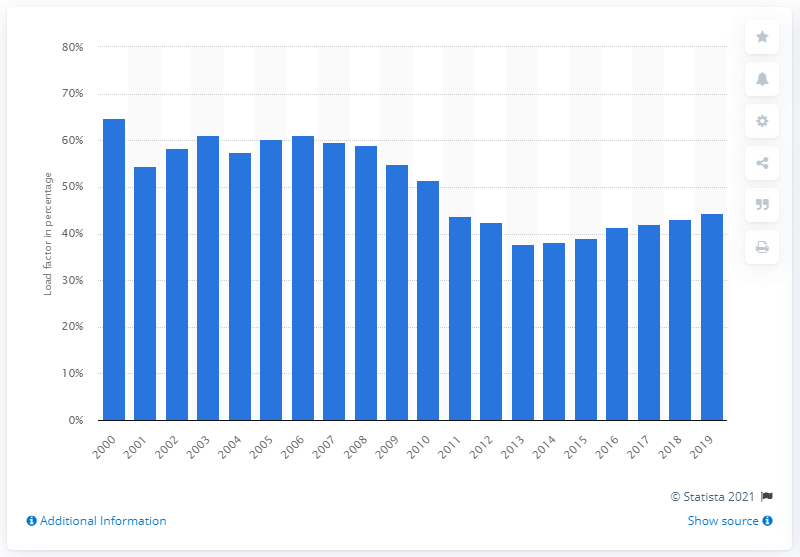Highlight a few significant elements in this photo. The load factor of Combined Heat and Power (CHP) in 2019 was 44.3%. 